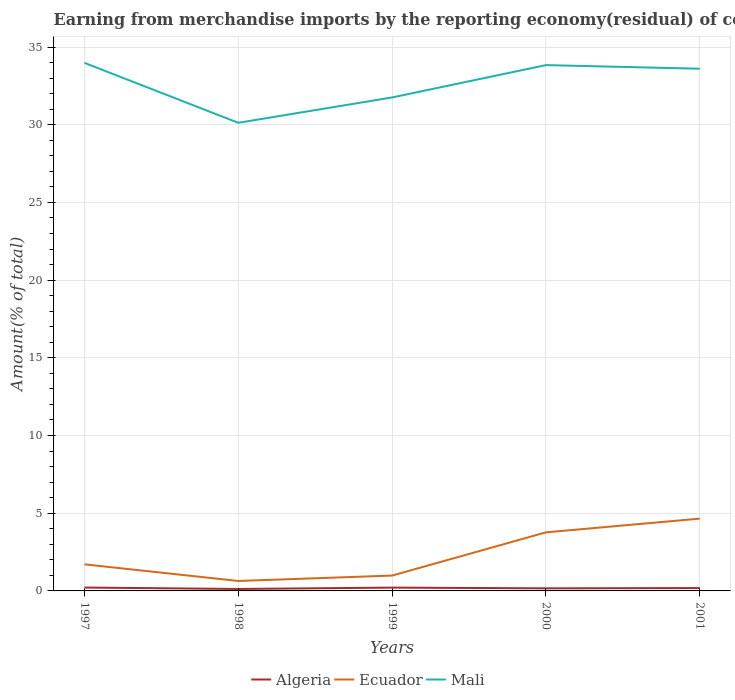Is the number of lines equal to the number of legend labels?
Your answer should be very brief. Yes. Across all years, what is the maximum percentage of amount earned from merchandise imports in Algeria?
Offer a very short reply. 0.13. What is the total percentage of amount earned from merchandise imports in Ecuador in the graph?
Offer a very short reply. -2.78. What is the difference between the highest and the second highest percentage of amount earned from merchandise imports in Mali?
Ensure brevity in your answer.  3.86. What is the difference between the highest and the lowest percentage of amount earned from merchandise imports in Ecuador?
Ensure brevity in your answer.  2. Is the percentage of amount earned from merchandise imports in Mali strictly greater than the percentage of amount earned from merchandise imports in Algeria over the years?
Ensure brevity in your answer.  No. How many years are there in the graph?
Give a very brief answer. 5. What is the difference between two consecutive major ticks on the Y-axis?
Offer a very short reply. 5. Does the graph contain any zero values?
Your answer should be compact. No. Does the graph contain grids?
Make the answer very short. Yes. What is the title of the graph?
Your answer should be compact. Earning from merchandise imports by the reporting economy(residual) of countries. Does "Denmark" appear as one of the legend labels in the graph?
Keep it short and to the point. No. What is the label or title of the X-axis?
Make the answer very short. Years. What is the label or title of the Y-axis?
Your answer should be very brief. Amount(% of total). What is the Amount(% of total) in Algeria in 1997?
Your answer should be compact. 0.22. What is the Amount(% of total) in Ecuador in 1997?
Your response must be concise. 1.71. What is the Amount(% of total) of Mali in 1997?
Provide a short and direct response. 33.98. What is the Amount(% of total) in Algeria in 1998?
Provide a succinct answer. 0.13. What is the Amount(% of total) of Ecuador in 1998?
Offer a very short reply. 0.64. What is the Amount(% of total) of Mali in 1998?
Your answer should be compact. 30.13. What is the Amount(% of total) in Algeria in 1999?
Make the answer very short. 0.21. What is the Amount(% of total) in Ecuador in 1999?
Ensure brevity in your answer.  0.99. What is the Amount(% of total) of Mali in 1999?
Offer a very short reply. 31.76. What is the Amount(% of total) in Algeria in 2000?
Keep it short and to the point. 0.17. What is the Amount(% of total) in Ecuador in 2000?
Offer a very short reply. 3.77. What is the Amount(% of total) in Mali in 2000?
Give a very brief answer. 33.84. What is the Amount(% of total) in Algeria in 2001?
Your answer should be compact. 0.18. What is the Amount(% of total) of Ecuador in 2001?
Provide a succinct answer. 4.65. What is the Amount(% of total) in Mali in 2001?
Give a very brief answer. 33.61. Across all years, what is the maximum Amount(% of total) in Algeria?
Your answer should be very brief. 0.22. Across all years, what is the maximum Amount(% of total) in Ecuador?
Give a very brief answer. 4.65. Across all years, what is the maximum Amount(% of total) of Mali?
Offer a terse response. 33.98. Across all years, what is the minimum Amount(% of total) in Algeria?
Your answer should be compact. 0.13. Across all years, what is the minimum Amount(% of total) of Ecuador?
Offer a very short reply. 0.64. Across all years, what is the minimum Amount(% of total) in Mali?
Ensure brevity in your answer.  30.13. What is the total Amount(% of total) in Algeria in the graph?
Make the answer very short. 0.9. What is the total Amount(% of total) of Ecuador in the graph?
Provide a short and direct response. 11.76. What is the total Amount(% of total) in Mali in the graph?
Your response must be concise. 163.31. What is the difference between the Amount(% of total) in Algeria in 1997 and that in 1998?
Your answer should be compact. 0.09. What is the difference between the Amount(% of total) in Ecuador in 1997 and that in 1998?
Offer a very short reply. 1.07. What is the difference between the Amount(% of total) of Mali in 1997 and that in 1998?
Provide a succinct answer. 3.86. What is the difference between the Amount(% of total) in Algeria in 1997 and that in 1999?
Your answer should be very brief. 0. What is the difference between the Amount(% of total) in Ecuador in 1997 and that in 1999?
Your answer should be compact. 0.72. What is the difference between the Amount(% of total) in Mali in 1997 and that in 1999?
Your answer should be very brief. 2.23. What is the difference between the Amount(% of total) in Algeria in 1997 and that in 2000?
Make the answer very short. 0.05. What is the difference between the Amount(% of total) of Ecuador in 1997 and that in 2000?
Your answer should be compact. -2.06. What is the difference between the Amount(% of total) in Mali in 1997 and that in 2000?
Ensure brevity in your answer.  0.14. What is the difference between the Amount(% of total) in Algeria in 1997 and that in 2001?
Your answer should be compact. 0.03. What is the difference between the Amount(% of total) in Ecuador in 1997 and that in 2001?
Offer a terse response. -2.94. What is the difference between the Amount(% of total) of Mali in 1997 and that in 2001?
Your answer should be compact. 0.38. What is the difference between the Amount(% of total) in Algeria in 1998 and that in 1999?
Provide a succinct answer. -0.09. What is the difference between the Amount(% of total) of Ecuador in 1998 and that in 1999?
Your answer should be very brief. -0.35. What is the difference between the Amount(% of total) in Mali in 1998 and that in 1999?
Give a very brief answer. -1.63. What is the difference between the Amount(% of total) in Algeria in 1998 and that in 2000?
Keep it short and to the point. -0.04. What is the difference between the Amount(% of total) in Ecuador in 1998 and that in 2000?
Offer a terse response. -3.13. What is the difference between the Amount(% of total) in Mali in 1998 and that in 2000?
Offer a very short reply. -3.71. What is the difference between the Amount(% of total) of Algeria in 1998 and that in 2001?
Offer a very short reply. -0.06. What is the difference between the Amount(% of total) in Ecuador in 1998 and that in 2001?
Keep it short and to the point. -4.01. What is the difference between the Amount(% of total) of Mali in 1998 and that in 2001?
Provide a short and direct response. -3.48. What is the difference between the Amount(% of total) in Algeria in 1999 and that in 2000?
Provide a succinct answer. 0.05. What is the difference between the Amount(% of total) in Ecuador in 1999 and that in 2000?
Offer a terse response. -2.78. What is the difference between the Amount(% of total) in Mali in 1999 and that in 2000?
Provide a short and direct response. -2.08. What is the difference between the Amount(% of total) of Algeria in 1999 and that in 2001?
Provide a succinct answer. 0.03. What is the difference between the Amount(% of total) in Ecuador in 1999 and that in 2001?
Make the answer very short. -3.66. What is the difference between the Amount(% of total) in Mali in 1999 and that in 2001?
Offer a terse response. -1.85. What is the difference between the Amount(% of total) in Algeria in 2000 and that in 2001?
Keep it short and to the point. -0.02. What is the difference between the Amount(% of total) in Ecuador in 2000 and that in 2001?
Your answer should be very brief. -0.88. What is the difference between the Amount(% of total) in Mali in 2000 and that in 2001?
Offer a terse response. 0.23. What is the difference between the Amount(% of total) in Algeria in 1997 and the Amount(% of total) in Ecuador in 1998?
Provide a succinct answer. -0.42. What is the difference between the Amount(% of total) in Algeria in 1997 and the Amount(% of total) in Mali in 1998?
Your answer should be compact. -29.91. What is the difference between the Amount(% of total) in Ecuador in 1997 and the Amount(% of total) in Mali in 1998?
Your answer should be compact. -28.42. What is the difference between the Amount(% of total) of Algeria in 1997 and the Amount(% of total) of Ecuador in 1999?
Offer a very short reply. -0.77. What is the difference between the Amount(% of total) of Algeria in 1997 and the Amount(% of total) of Mali in 1999?
Provide a succinct answer. -31.54. What is the difference between the Amount(% of total) in Ecuador in 1997 and the Amount(% of total) in Mali in 1999?
Make the answer very short. -30.05. What is the difference between the Amount(% of total) in Algeria in 1997 and the Amount(% of total) in Ecuador in 2000?
Keep it short and to the point. -3.55. What is the difference between the Amount(% of total) in Algeria in 1997 and the Amount(% of total) in Mali in 2000?
Provide a succinct answer. -33.62. What is the difference between the Amount(% of total) in Ecuador in 1997 and the Amount(% of total) in Mali in 2000?
Offer a terse response. -32.13. What is the difference between the Amount(% of total) of Algeria in 1997 and the Amount(% of total) of Ecuador in 2001?
Ensure brevity in your answer.  -4.44. What is the difference between the Amount(% of total) of Algeria in 1997 and the Amount(% of total) of Mali in 2001?
Offer a very short reply. -33.39. What is the difference between the Amount(% of total) of Ecuador in 1997 and the Amount(% of total) of Mali in 2001?
Offer a terse response. -31.9. What is the difference between the Amount(% of total) of Algeria in 1998 and the Amount(% of total) of Ecuador in 1999?
Make the answer very short. -0.86. What is the difference between the Amount(% of total) of Algeria in 1998 and the Amount(% of total) of Mali in 1999?
Offer a very short reply. -31.63. What is the difference between the Amount(% of total) in Ecuador in 1998 and the Amount(% of total) in Mali in 1999?
Your answer should be compact. -31.12. What is the difference between the Amount(% of total) of Algeria in 1998 and the Amount(% of total) of Ecuador in 2000?
Provide a short and direct response. -3.64. What is the difference between the Amount(% of total) in Algeria in 1998 and the Amount(% of total) in Mali in 2000?
Keep it short and to the point. -33.71. What is the difference between the Amount(% of total) in Ecuador in 1998 and the Amount(% of total) in Mali in 2000?
Make the answer very short. -33.2. What is the difference between the Amount(% of total) in Algeria in 1998 and the Amount(% of total) in Ecuador in 2001?
Keep it short and to the point. -4.53. What is the difference between the Amount(% of total) of Algeria in 1998 and the Amount(% of total) of Mali in 2001?
Provide a succinct answer. -33.48. What is the difference between the Amount(% of total) of Ecuador in 1998 and the Amount(% of total) of Mali in 2001?
Ensure brevity in your answer.  -32.97. What is the difference between the Amount(% of total) in Algeria in 1999 and the Amount(% of total) in Ecuador in 2000?
Ensure brevity in your answer.  -3.56. What is the difference between the Amount(% of total) in Algeria in 1999 and the Amount(% of total) in Mali in 2000?
Offer a terse response. -33.63. What is the difference between the Amount(% of total) of Ecuador in 1999 and the Amount(% of total) of Mali in 2000?
Your answer should be very brief. -32.85. What is the difference between the Amount(% of total) in Algeria in 1999 and the Amount(% of total) in Ecuador in 2001?
Provide a short and direct response. -4.44. What is the difference between the Amount(% of total) of Algeria in 1999 and the Amount(% of total) of Mali in 2001?
Your response must be concise. -33.39. What is the difference between the Amount(% of total) of Ecuador in 1999 and the Amount(% of total) of Mali in 2001?
Provide a short and direct response. -32.62. What is the difference between the Amount(% of total) in Algeria in 2000 and the Amount(% of total) in Ecuador in 2001?
Give a very brief answer. -4.49. What is the difference between the Amount(% of total) in Algeria in 2000 and the Amount(% of total) in Mali in 2001?
Offer a terse response. -33.44. What is the difference between the Amount(% of total) of Ecuador in 2000 and the Amount(% of total) of Mali in 2001?
Provide a succinct answer. -29.84. What is the average Amount(% of total) of Algeria per year?
Provide a succinct answer. 0.18. What is the average Amount(% of total) of Ecuador per year?
Your answer should be compact. 2.35. What is the average Amount(% of total) in Mali per year?
Keep it short and to the point. 32.66. In the year 1997, what is the difference between the Amount(% of total) of Algeria and Amount(% of total) of Ecuador?
Offer a very short reply. -1.49. In the year 1997, what is the difference between the Amount(% of total) of Algeria and Amount(% of total) of Mali?
Your response must be concise. -33.77. In the year 1997, what is the difference between the Amount(% of total) in Ecuador and Amount(% of total) in Mali?
Offer a very short reply. -32.27. In the year 1998, what is the difference between the Amount(% of total) in Algeria and Amount(% of total) in Ecuador?
Provide a succinct answer. -0.51. In the year 1998, what is the difference between the Amount(% of total) in Algeria and Amount(% of total) in Mali?
Keep it short and to the point. -30. In the year 1998, what is the difference between the Amount(% of total) of Ecuador and Amount(% of total) of Mali?
Offer a very short reply. -29.49. In the year 1999, what is the difference between the Amount(% of total) of Algeria and Amount(% of total) of Ecuador?
Offer a very short reply. -0.78. In the year 1999, what is the difference between the Amount(% of total) in Algeria and Amount(% of total) in Mali?
Offer a terse response. -31.54. In the year 1999, what is the difference between the Amount(% of total) of Ecuador and Amount(% of total) of Mali?
Your response must be concise. -30.77. In the year 2000, what is the difference between the Amount(% of total) of Algeria and Amount(% of total) of Ecuador?
Your answer should be very brief. -3.6. In the year 2000, what is the difference between the Amount(% of total) of Algeria and Amount(% of total) of Mali?
Provide a succinct answer. -33.67. In the year 2000, what is the difference between the Amount(% of total) of Ecuador and Amount(% of total) of Mali?
Your response must be concise. -30.07. In the year 2001, what is the difference between the Amount(% of total) of Algeria and Amount(% of total) of Ecuador?
Ensure brevity in your answer.  -4.47. In the year 2001, what is the difference between the Amount(% of total) in Algeria and Amount(% of total) in Mali?
Give a very brief answer. -33.42. In the year 2001, what is the difference between the Amount(% of total) of Ecuador and Amount(% of total) of Mali?
Provide a succinct answer. -28.95. What is the ratio of the Amount(% of total) of Algeria in 1997 to that in 1998?
Offer a terse response. 1.73. What is the ratio of the Amount(% of total) of Ecuador in 1997 to that in 1998?
Provide a succinct answer. 2.67. What is the ratio of the Amount(% of total) in Mali in 1997 to that in 1998?
Provide a short and direct response. 1.13. What is the ratio of the Amount(% of total) in Algeria in 1997 to that in 1999?
Provide a short and direct response. 1.02. What is the ratio of the Amount(% of total) of Ecuador in 1997 to that in 1999?
Offer a very short reply. 1.73. What is the ratio of the Amount(% of total) of Mali in 1997 to that in 1999?
Your response must be concise. 1.07. What is the ratio of the Amount(% of total) of Algeria in 1997 to that in 2000?
Keep it short and to the point. 1.31. What is the ratio of the Amount(% of total) in Ecuador in 1997 to that in 2000?
Keep it short and to the point. 0.45. What is the ratio of the Amount(% of total) in Mali in 1997 to that in 2000?
Keep it short and to the point. 1. What is the ratio of the Amount(% of total) of Algeria in 1997 to that in 2001?
Provide a succinct answer. 1.18. What is the ratio of the Amount(% of total) of Ecuador in 1997 to that in 2001?
Provide a short and direct response. 0.37. What is the ratio of the Amount(% of total) in Mali in 1997 to that in 2001?
Provide a succinct answer. 1.01. What is the ratio of the Amount(% of total) in Algeria in 1998 to that in 1999?
Make the answer very short. 0.59. What is the ratio of the Amount(% of total) of Ecuador in 1998 to that in 1999?
Your answer should be compact. 0.65. What is the ratio of the Amount(% of total) in Mali in 1998 to that in 1999?
Make the answer very short. 0.95. What is the ratio of the Amount(% of total) of Algeria in 1998 to that in 2000?
Offer a terse response. 0.76. What is the ratio of the Amount(% of total) of Ecuador in 1998 to that in 2000?
Your answer should be compact. 0.17. What is the ratio of the Amount(% of total) in Mali in 1998 to that in 2000?
Ensure brevity in your answer.  0.89. What is the ratio of the Amount(% of total) in Algeria in 1998 to that in 2001?
Make the answer very short. 0.68. What is the ratio of the Amount(% of total) in Ecuador in 1998 to that in 2001?
Ensure brevity in your answer.  0.14. What is the ratio of the Amount(% of total) of Mali in 1998 to that in 2001?
Give a very brief answer. 0.9. What is the ratio of the Amount(% of total) of Algeria in 1999 to that in 2000?
Keep it short and to the point. 1.29. What is the ratio of the Amount(% of total) of Ecuador in 1999 to that in 2000?
Make the answer very short. 0.26. What is the ratio of the Amount(% of total) in Mali in 1999 to that in 2000?
Provide a short and direct response. 0.94. What is the ratio of the Amount(% of total) in Algeria in 1999 to that in 2001?
Keep it short and to the point. 1.16. What is the ratio of the Amount(% of total) of Ecuador in 1999 to that in 2001?
Offer a terse response. 0.21. What is the ratio of the Amount(% of total) of Mali in 1999 to that in 2001?
Your answer should be very brief. 0.94. What is the ratio of the Amount(% of total) in Algeria in 2000 to that in 2001?
Offer a very short reply. 0.9. What is the ratio of the Amount(% of total) in Ecuador in 2000 to that in 2001?
Your answer should be very brief. 0.81. What is the ratio of the Amount(% of total) in Mali in 2000 to that in 2001?
Offer a very short reply. 1.01. What is the difference between the highest and the second highest Amount(% of total) in Algeria?
Offer a very short reply. 0. What is the difference between the highest and the second highest Amount(% of total) in Ecuador?
Your response must be concise. 0.88. What is the difference between the highest and the second highest Amount(% of total) in Mali?
Your response must be concise. 0.14. What is the difference between the highest and the lowest Amount(% of total) in Algeria?
Give a very brief answer. 0.09. What is the difference between the highest and the lowest Amount(% of total) of Ecuador?
Your answer should be very brief. 4.01. What is the difference between the highest and the lowest Amount(% of total) of Mali?
Offer a terse response. 3.86. 